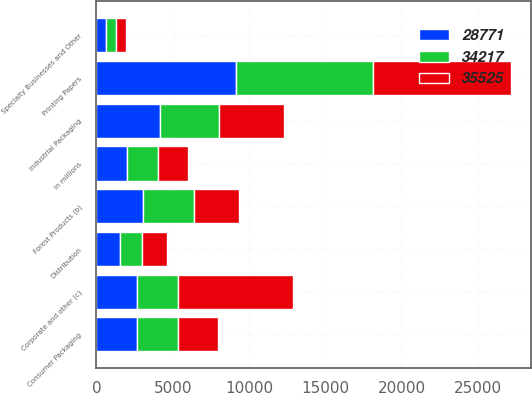Convert chart. <chart><loc_0><loc_0><loc_500><loc_500><stacked_bar_chart><ecel><fcel>In millions<fcel>Printing Papers<fcel>Industrial Packaging<fcel>Consumer Packaging<fcel>Distribution<fcel>Forest Products (b)<fcel>Specialty Businesses and Other<fcel>Corporate and other (c)<nl><fcel>35525<fcel>2005<fcel>9033<fcel>4259<fcel>2647<fcel>1624<fcel>2973<fcel>652<fcel>7583<nl><fcel>28771<fcel>2004<fcel>9171<fcel>4184<fcel>2681<fcel>1515<fcel>3068<fcel>652<fcel>2665<nl><fcel>34217<fcel>2003<fcel>8953<fcel>3845<fcel>2649<fcel>1458<fcel>3324<fcel>626<fcel>2665<nl></chart> 